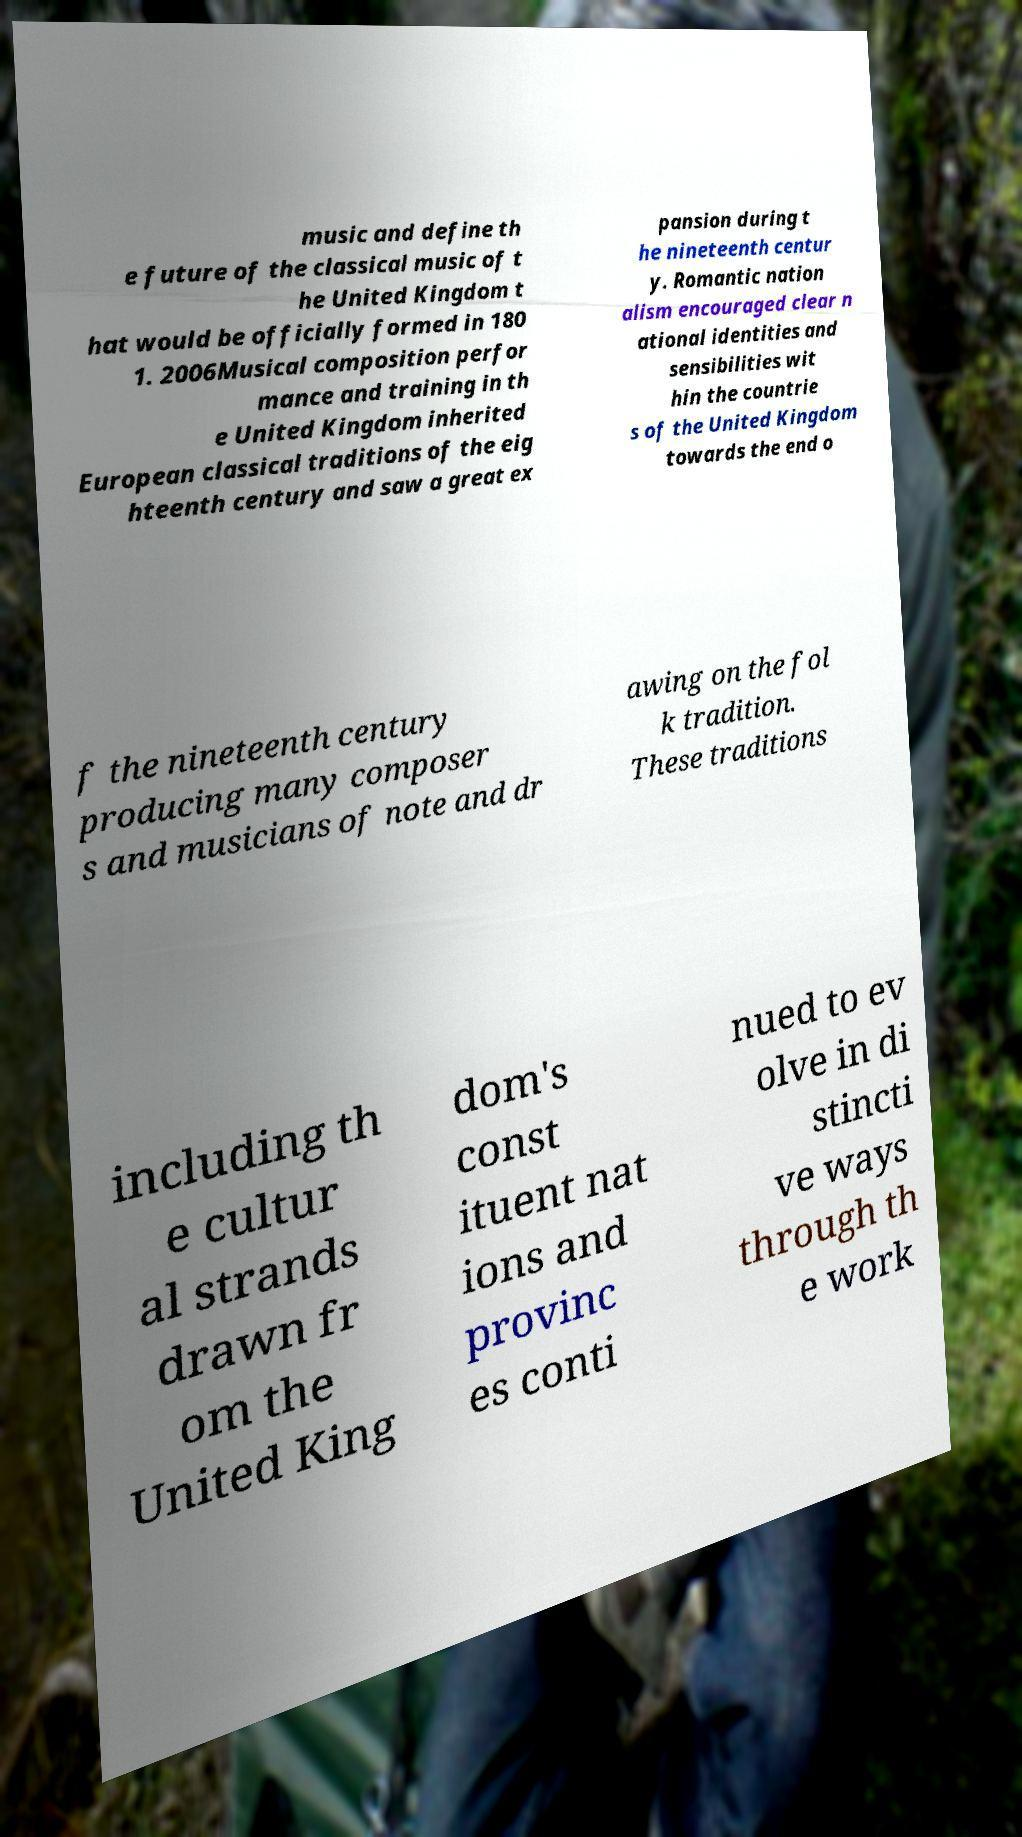Please read and relay the text visible in this image. What does it say? music and define th e future of the classical music of t he United Kingdom t hat would be officially formed in 180 1. 2006Musical composition perfor mance and training in th e United Kingdom inherited European classical traditions of the eig hteenth century and saw a great ex pansion during t he nineteenth centur y. Romantic nation alism encouraged clear n ational identities and sensibilities wit hin the countrie s of the United Kingdom towards the end o f the nineteenth century producing many composer s and musicians of note and dr awing on the fol k tradition. These traditions including th e cultur al strands drawn fr om the United King dom's const ituent nat ions and provinc es conti nued to ev olve in di stincti ve ways through th e work 